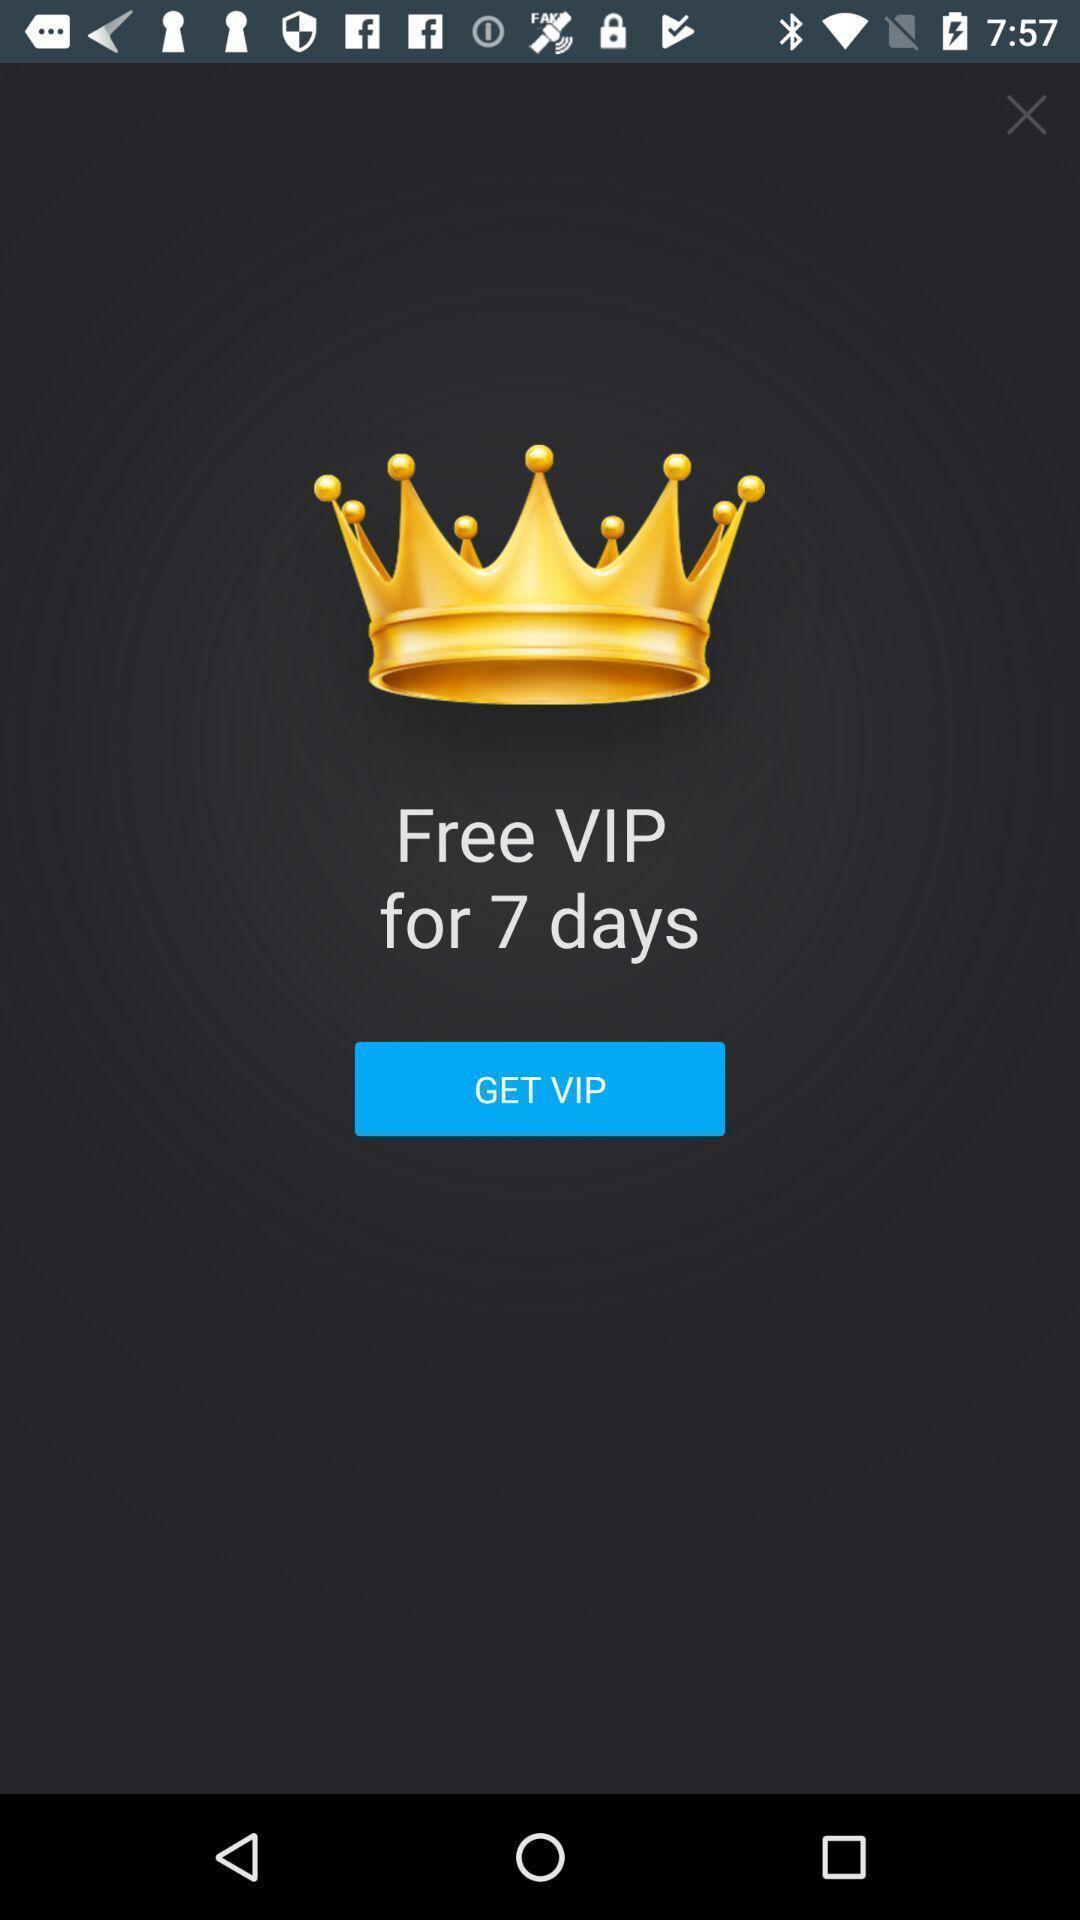Tell me about the visual elements in this screen capture. Screen page displaying an option. 